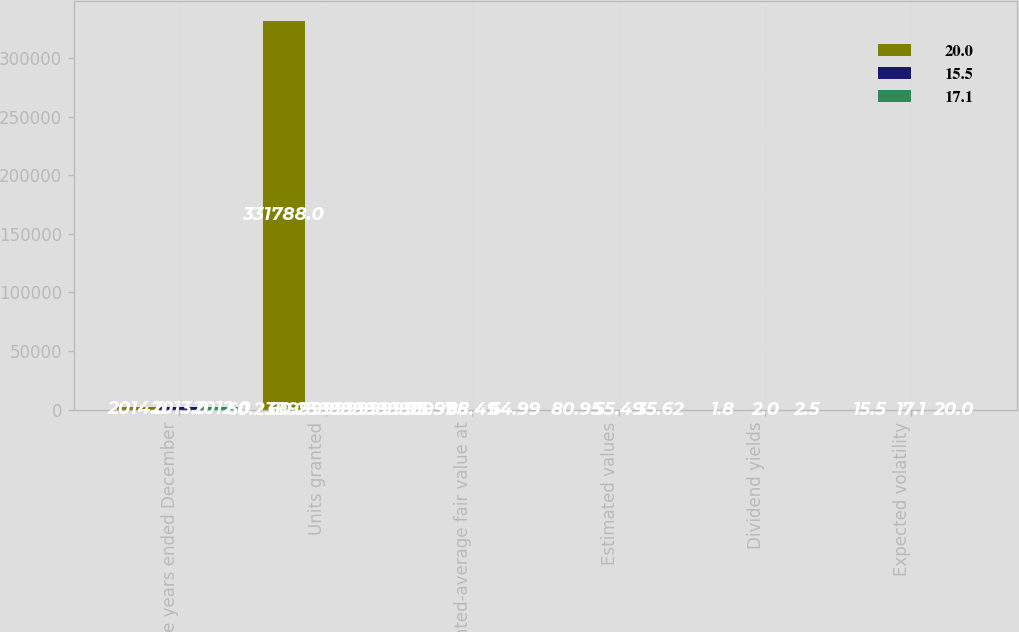<chart> <loc_0><loc_0><loc_500><loc_500><stacked_bar_chart><ecel><fcel>For the years ended December<fcel>Units granted<fcel>Weighted-average fair value at<fcel>Estimated values<fcel>Dividend yields<fcel>Expected volatility<nl><fcel>20<fcel>2014<fcel>331788<fcel>115.57<fcel>80.95<fcel>1.8<fcel>15.5<nl><fcel>15.5<fcel>2013<fcel>60.24<fcel>88.49<fcel>55.49<fcel>2<fcel>17.1<nl><fcel>17.1<fcel>2012<fcel>60.24<fcel>64.99<fcel>35.62<fcel>2.5<fcel>20<nl></chart> 